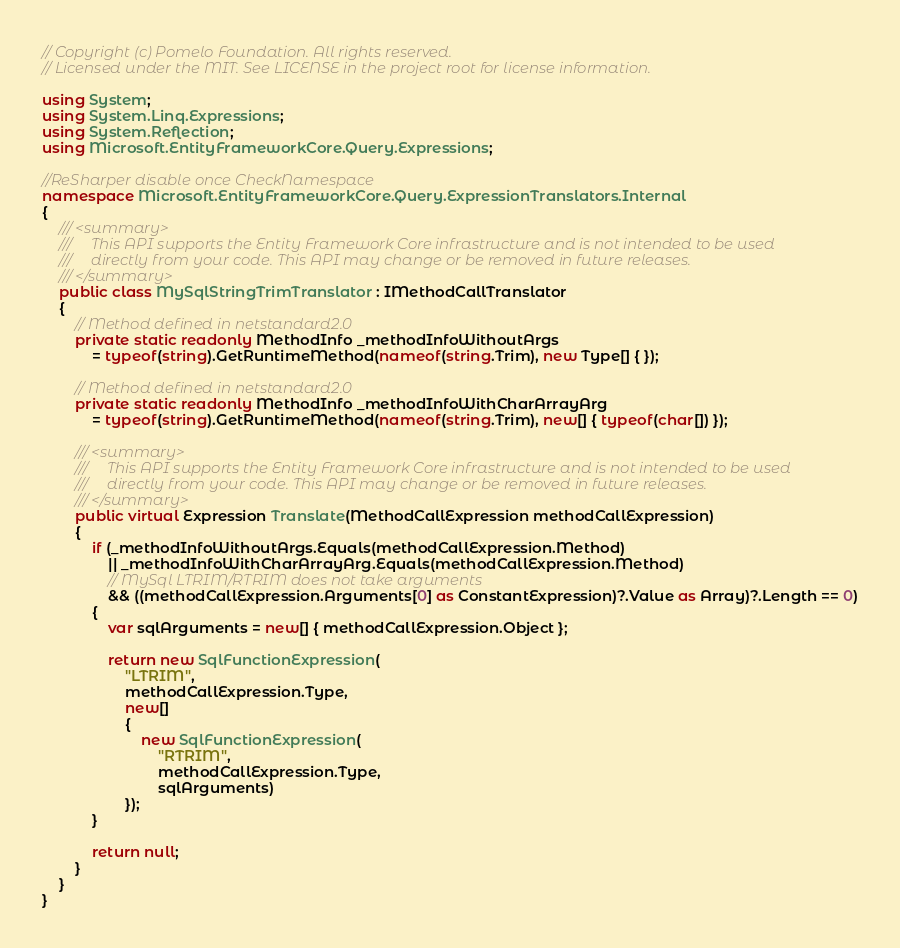<code> <loc_0><loc_0><loc_500><loc_500><_C#_>// Copyright (c) Pomelo Foundation. All rights reserved.
// Licensed under the MIT. See LICENSE in the project root for license information.

using System;
using System.Linq.Expressions;
using System.Reflection;
using Microsoft.EntityFrameworkCore.Query.Expressions;

//ReSharper disable once CheckNamespace
namespace Microsoft.EntityFrameworkCore.Query.ExpressionTranslators.Internal
{
    /// <summary>
    ///     This API supports the Entity Framework Core infrastructure and is not intended to be used
    ///     directly from your code. This API may change or be removed in future releases.
    /// </summary>
    public class MySqlStringTrimTranslator : IMethodCallTranslator
    {
        // Method defined in netstandard2.0
        private static readonly MethodInfo _methodInfoWithoutArgs
            = typeof(string).GetRuntimeMethod(nameof(string.Trim), new Type[] { });

        // Method defined in netstandard2.0
        private static readonly MethodInfo _methodInfoWithCharArrayArg
            = typeof(string).GetRuntimeMethod(nameof(string.Trim), new[] { typeof(char[]) });

        /// <summary>
        ///     This API supports the Entity Framework Core infrastructure and is not intended to be used
        ///     directly from your code. This API may change or be removed in future releases.
        /// </summary>
        public virtual Expression Translate(MethodCallExpression methodCallExpression)
        {
            if (_methodInfoWithoutArgs.Equals(methodCallExpression.Method)
                || _methodInfoWithCharArrayArg.Equals(methodCallExpression.Method)
                // MySql LTRIM/RTRIM does not take arguments
                && ((methodCallExpression.Arguments[0] as ConstantExpression)?.Value as Array)?.Length == 0)
            {
                var sqlArguments = new[] { methodCallExpression.Object };

                return new SqlFunctionExpression(
                    "LTRIM",
                    methodCallExpression.Type,
                    new[]
                    {
                        new SqlFunctionExpression(
                            "RTRIM",
                            methodCallExpression.Type,
                            sqlArguments)
                    });
            }

            return null;
        }
    }
}
</code> 